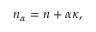Convert formula to latex. <formula><loc_0><loc_0><loc_500><loc_500>\begin{array} { r } { n _ { \alpha } = n + \alpha \kappa , } \end{array}</formula> 